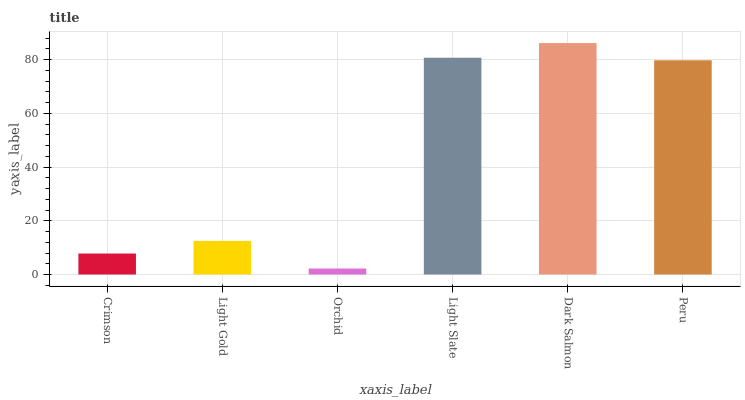Is Orchid the minimum?
Answer yes or no. Yes. Is Dark Salmon the maximum?
Answer yes or no. Yes. Is Light Gold the minimum?
Answer yes or no. No. Is Light Gold the maximum?
Answer yes or no. No. Is Light Gold greater than Crimson?
Answer yes or no. Yes. Is Crimson less than Light Gold?
Answer yes or no. Yes. Is Crimson greater than Light Gold?
Answer yes or no. No. Is Light Gold less than Crimson?
Answer yes or no. No. Is Peru the high median?
Answer yes or no. Yes. Is Light Gold the low median?
Answer yes or no. Yes. Is Orchid the high median?
Answer yes or no. No. Is Crimson the low median?
Answer yes or no. No. 